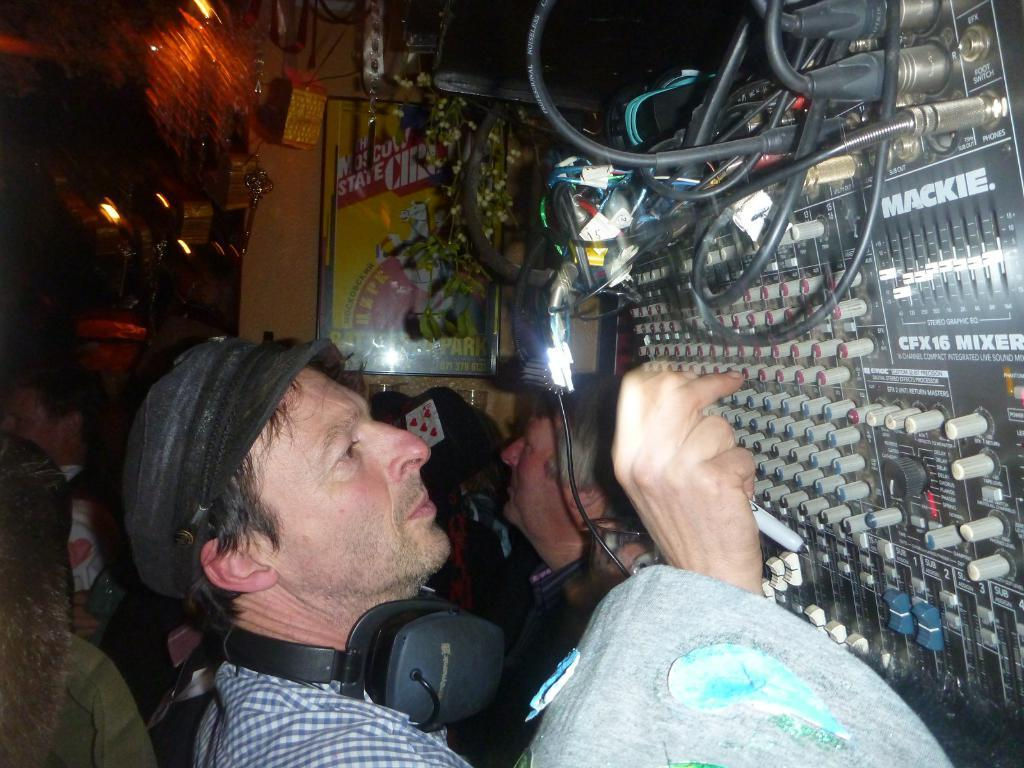How many people are in the image? There is a group of people in the image, but the exact number cannot be determined from the provided facts. What is the position of the people in the image? The people are on the floor in the image. What other items can be seen in the image besides the people? There are objects, wires, lights, and boards in the image. Can you describe the setting where the image might have been taken? The image may have been taken in a hall, based on the presence of boards and the arrangement of people and objects. What is the price of the furniture in the image? There is no furniture present in the image, so it is not possible to determine the price. 